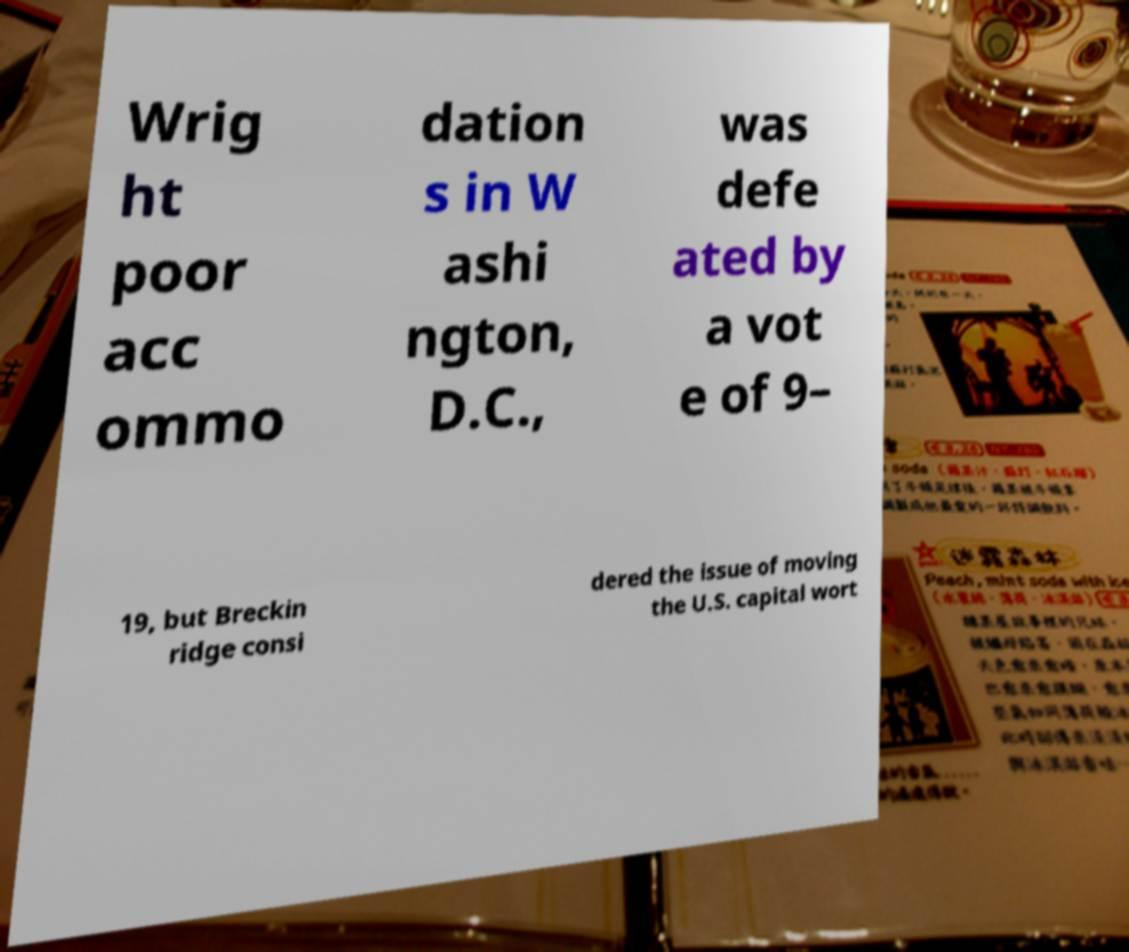For documentation purposes, I need the text within this image transcribed. Could you provide that? Wrig ht poor acc ommo dation s in W ashi ngton, D.C., was defe ated by a vot e of 9– 19, but Breckin ridge consi dered the issue of moving the U.S. capital wort 